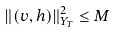Convert formula to latex. <formula><loc_0><loc_0><loc_500><loc_500>\| ( v , h ) \| ^ { 2 } _ { Y _ { T } } \leq M</formula> 